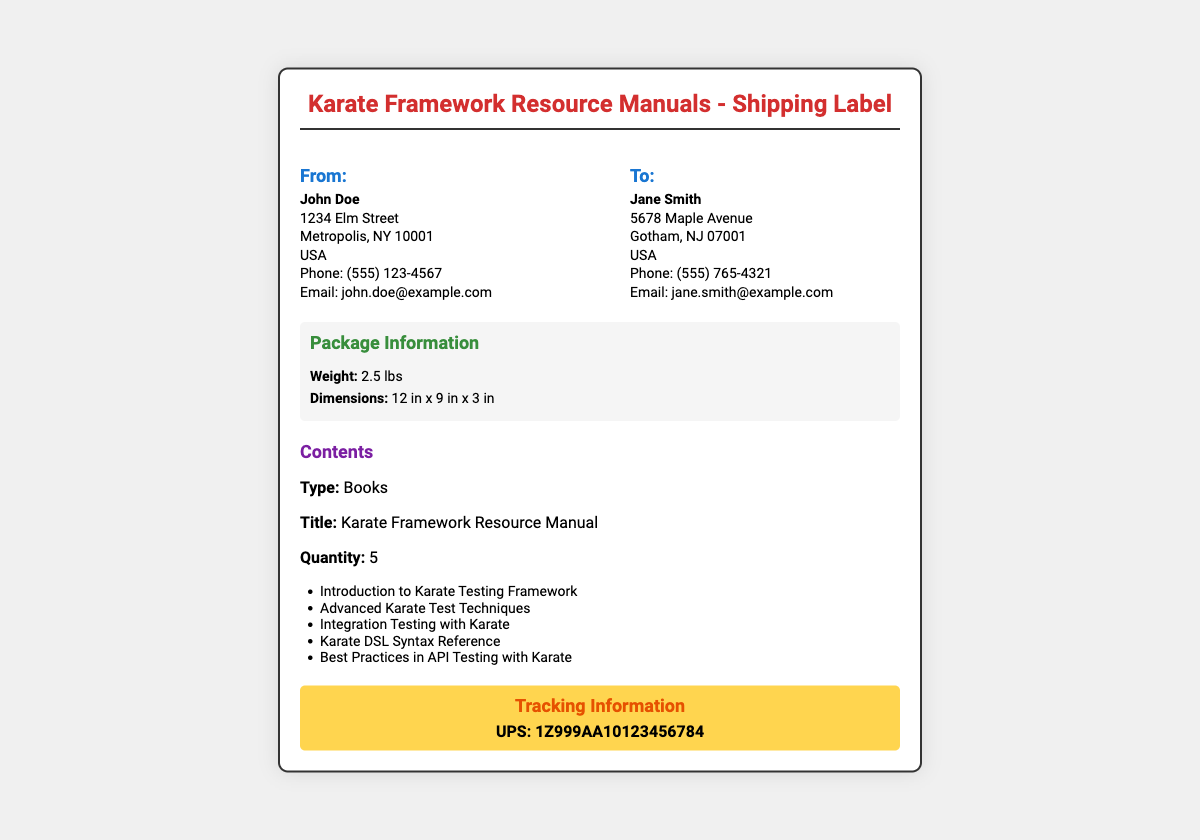What is the sender's name? The sender's name is clearly indicated under the "From:" section of the address.
Answer: John Doe What is the recipient's phone number? The recipient's phone number is found under the "To:" section of the address.
Answer: (555) 765-4321 What is the weight of the package? The weight is stated in the "Package Information" section.
Answer: 2.5 lbs What are the dimensions of the package? The package dimensions can be found alongside the weight in the "Package Information" section.
Answer: 12 in x 9 in x 3 in How many Karate Framework Resource Manuals are being sent? The quantity is listed in the "Contents" section of the document.
Answer: 5 What is the type of the contents? The type is specified in the "Contents" section.
Answer: Books What is the tracking number? The tracking number is provided in the "Tracking Information" section.
Answer: 1Z999AA10123456784 Where is the sender located? The sender's location is found in the "From:" section where the full address is presented.
Answer: 1234 Elm Street, Metropolis, NY 10001, USA What is the email address of the recipient? The recipient's email address is found in the "To:" section, following the phone number.
Answer: jane.smith@example.com 